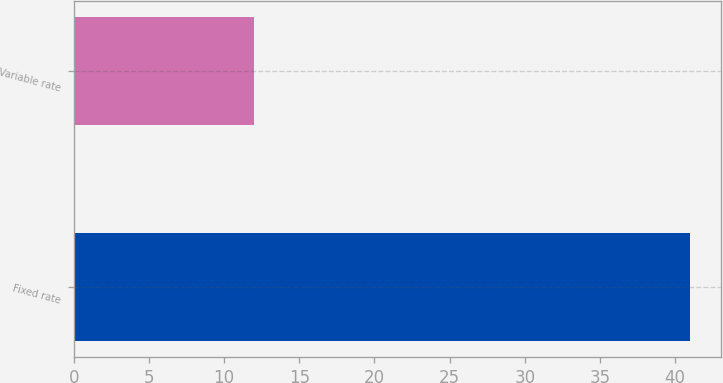Convert chart to OTSL. <chart><loc_0><loc_0><loc_500><loc_500><bar_chart><fcel>Fixed rate<fcel>Variable rate<nl><fcel>41<fcel>12<nl></chart> 